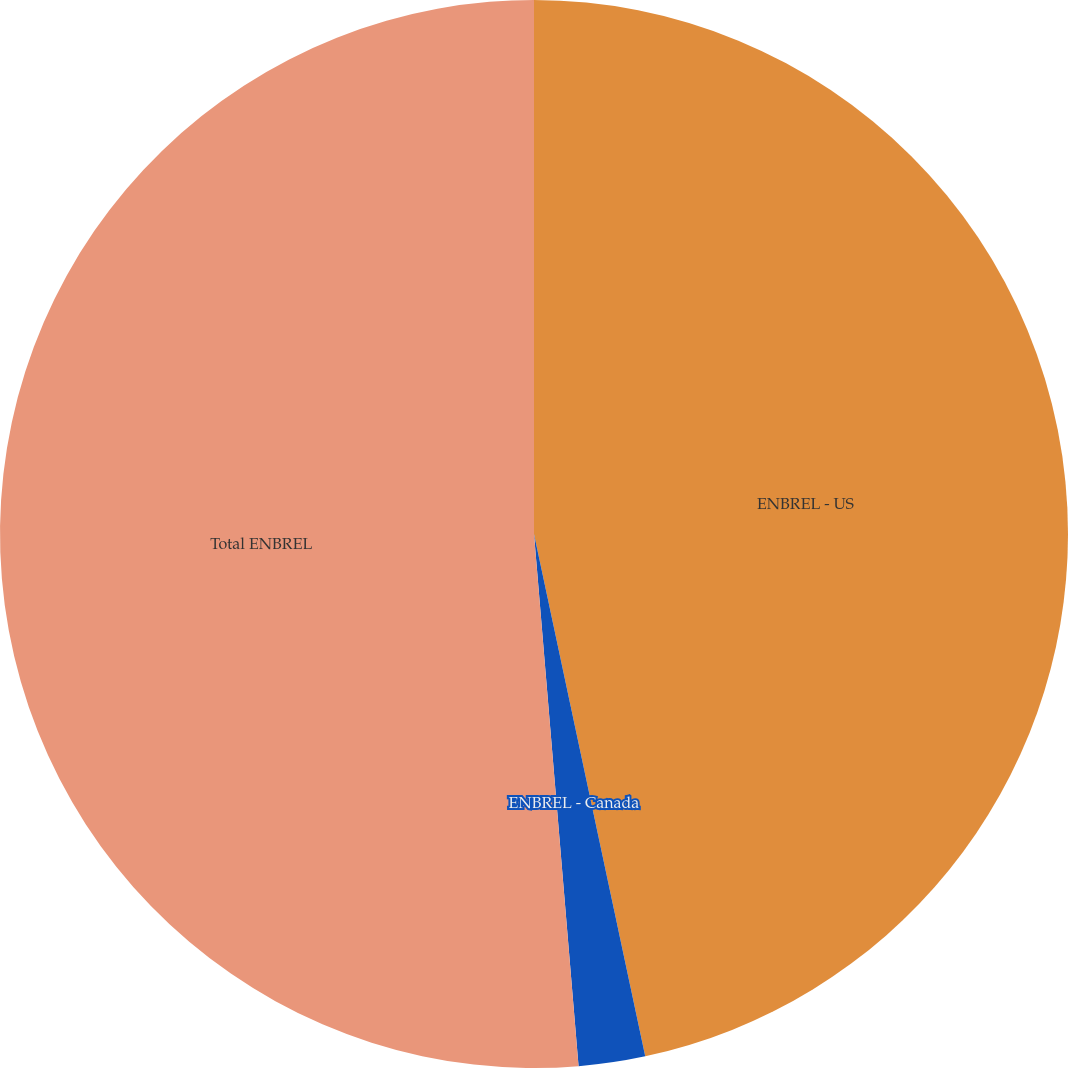Convert chart to OTSL. <chart><loc_0><loc_0><loc_500><loc_500><pie_chart><fcel>ENBREL - US<fcel>ENBREL - Canada<fcel>Total ENBREL<nl><fcel>46.66%<fcel>2.01%<fcel>51.33%<nl></chart> 